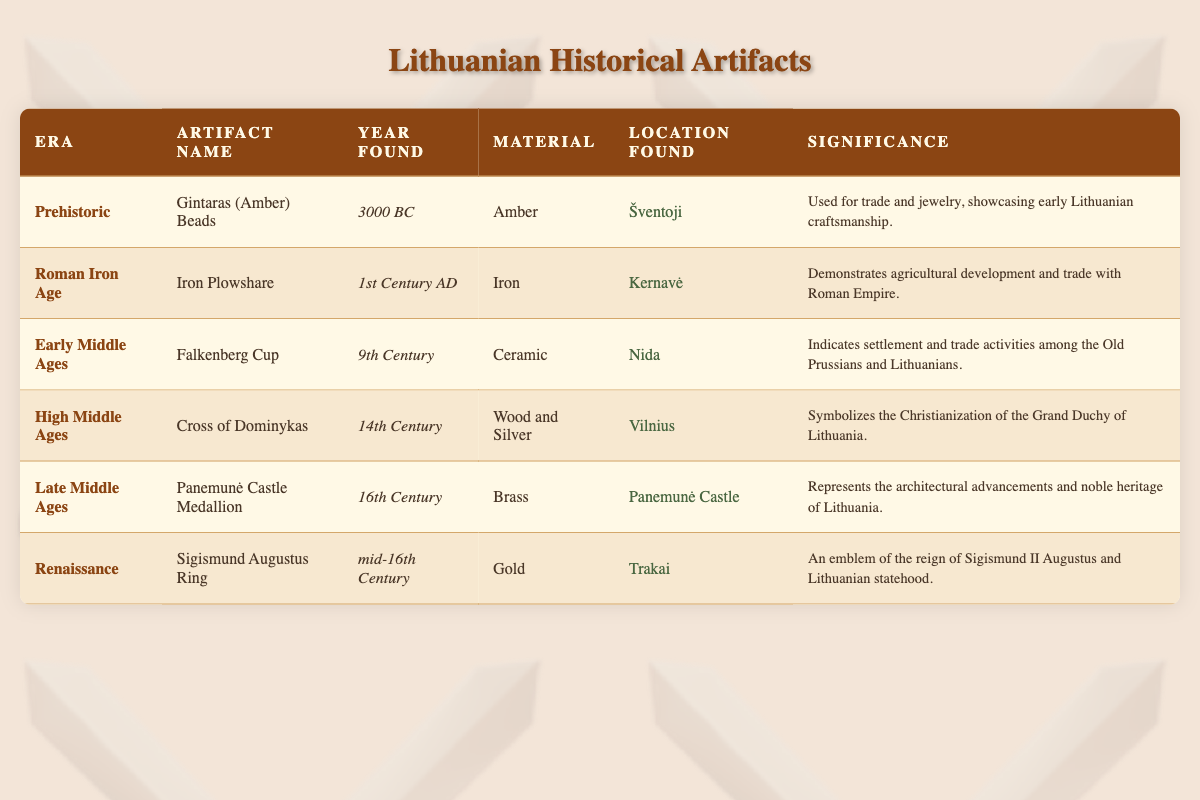What era is the "Falkenberg Cup" from? The "Falkenberg Cup" is listed under the "Early Middle Ages" in the table. Therefore, the era of this artifact is "Early Middle Ages."
Answer: Early Middle Ages What material is the "Cross of Dominykas" made from? In the table, the "Cross of Dominykas" is noted to be made from "Wood and Silver."
Answer: Wood and Silver Which artifact represents the architectural advancements of Lithuania? The artifact that represents architectural advancements is the "Panemunė Castle Medallion," as stated in its significance.
Answer: Panemunė Castle Medallion Did any artifacts date back to the Roman Iron Age? Yes, there is an artifact from the Roman Iron Age in the table, which is the "Iron Plowshare."
Answer: Yes What is the difference in years between the earliest and the latest artifacts? The earliest artifact is dated 3000 BC, and the latest one is from the mid-16th Century (approximately 1550 AD). To find the difference: 3000 + 1550 = 4550 years.
Answer: 4550 years Which artifact was found in Trakai, and what is its significance? The artifact found in Trakai is the "Sigismund Augustus Ring." Its significance is that it is an emblem of the reign of Sigismund II Augustus and Lithuanian statehood.
Answer: Sigismund Augustus Ring; emblem of statehood Is the Iron Plowshare significant for indicating trade with the Roman Empire? Yes, the table states that the Iron Plowshare demonstrates agricultural development and trade with the Roman Empire.
Answer: Yes What materials were used to create artifacts from the High Middle Ages and Renaissance? The "Cross of Dominykas" from the High Middle Ages is made of "Wood and Silver," and the "Sigismund Augustus Ring" from the Renaissance is made of "Gold." This requires checking both rows for the respective eras.
Answer: Wood and Silver; Gold How many artifacts mention trade in their significance? Two artifacts mention trade in their significance: the "Gintaras (Amber) Beads" and the "Iron Plowshare." Therefore, I count those and arrive at the total.
Answer: 2 